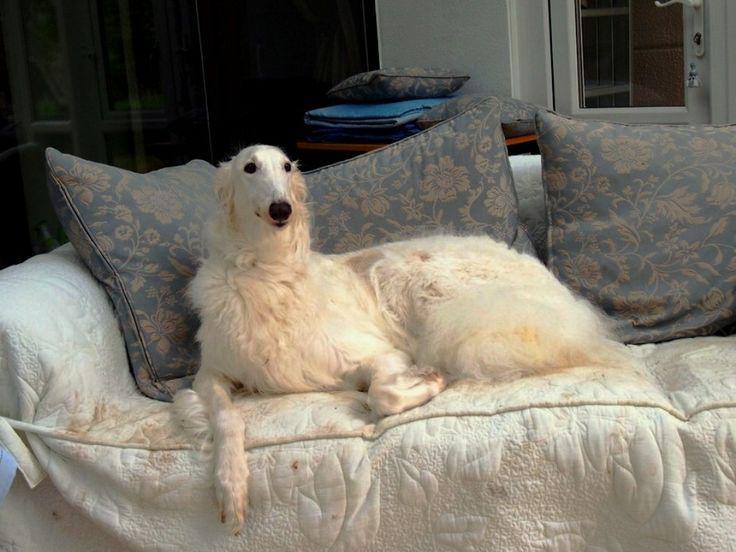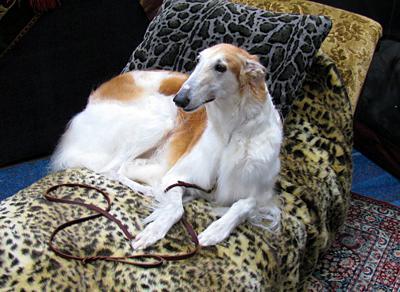The first image is the image on the left, the second image is the image on the right. Assess this claim about the two images: "The right image contains at least two dogs laying down on a couch.". Correct or not? Answer yes or no. No. The first image is the image on the left, the second image is the image on the right. Evaluate the accuracy of this statement regarding the images: "There are two dogs lying on the couch in the image on the right.". Is it true? Answer yes or no. No. 